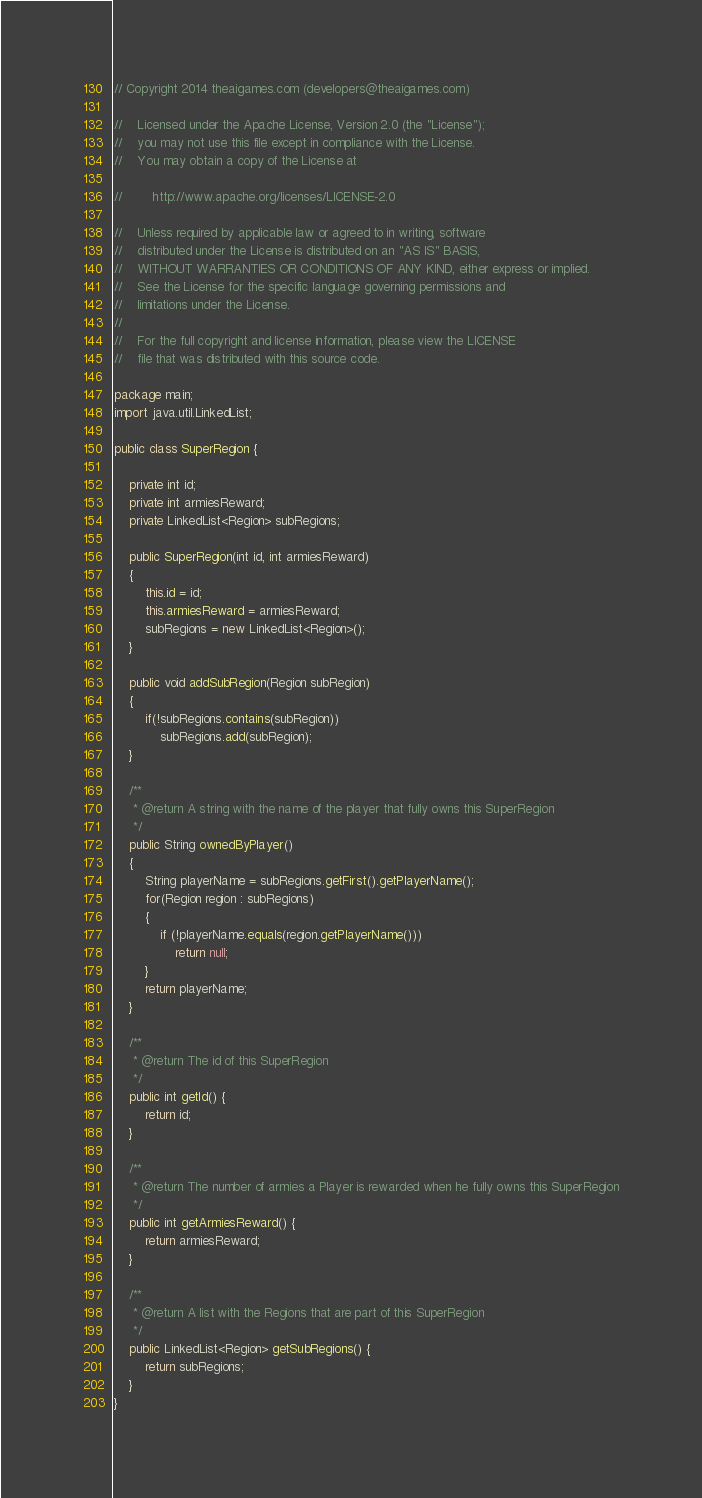<code> <loc_0><loc_0><loc_500><loc_500><_Java_>// Copyright 2014 theaigames.com (developers@theaigames.com)

//    Licensed under the Apache License, Version 2.0 (the "License");
//    you may not use this file except in compliance with the License.
//    You may obtain a copy of the License at

//        http://www.apache.org/licenses/LICENSE-2.0

//    Unless required by applicable law or agreed to in writing, software
//    distributed under the License is distributed on an "AS IS" BASIS,
//    WITHOUT WARRANTIES OR CONDITIONS OF ANY KIND, either express or implied.
//    See the License for the specific language governing permissions and
//    limitations under the License.
//	
//    For the full copyright and license information, please view the LICENSE
//    file that was distributed with this source code.

package main;
import java.util.LinkedList;

public class SuperRegion {
	
	private int id;
	private int armiesReward;
	private LinkedList<Region> subRegions;
	
	public SuperRegion(int id, int armiesReward)
	{
		this.id = id;
		this.armiesReward = armiesReward;
		subRegions = new LinkedList<Region>();
	}
	
	public void addSubRegion(Region subRegion)
	{
		if(!subRegions.contains(subRegion))
			subRegions.add(subRegion);
	}
	
	/**
	 * @return A string with the name of the player that fully owns this SuperRegion
	 */
	public String ownedByPlayer()
	{
		String playerName = subRegions.getFirst().getPlayerName();
		for(Region region : subRegions)
		{
			if (!playerName.equals(region.getPlayerName()))
				return null;
		}
		return playerName;
	}
	
	/**
	 * @return The id of this SuperRegion
	 */
	public int getId() {
		return id;
	}
	
	/**
	 * @return The number of armies a Player is rewarded when he fully owns this SuperRegion
	 */
	public int getArmiesReward() {
		return armiesReward;
	}
	
	/**
	 * @return A list with the Regions that are part of this SuperRegion
	 */
	public LinkedList<Region> getSubRegions() {
		return subRegions;
	}
}
</code> 